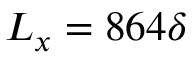<formula> <loc_0><loc_0><loc_500><loc_500>L _ { x } = 8 6 4 \delta</formula> 